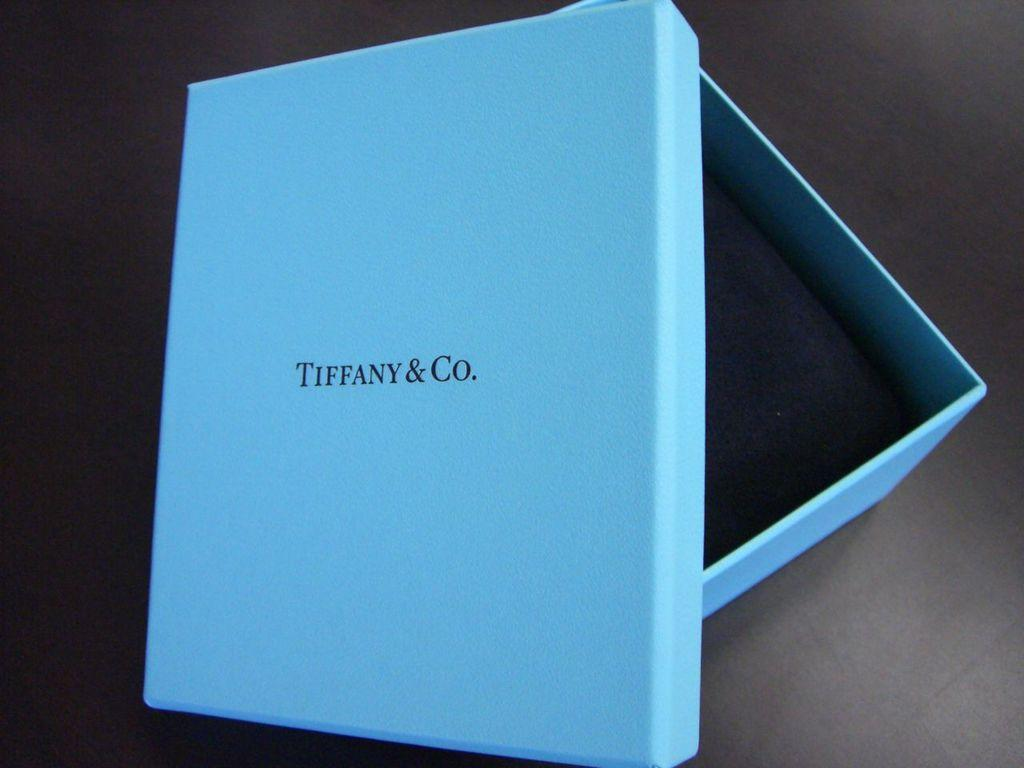<image>
Offer a succinct explanation of the picture presented. A blue box from Tiffany and Company sits on a black table. 